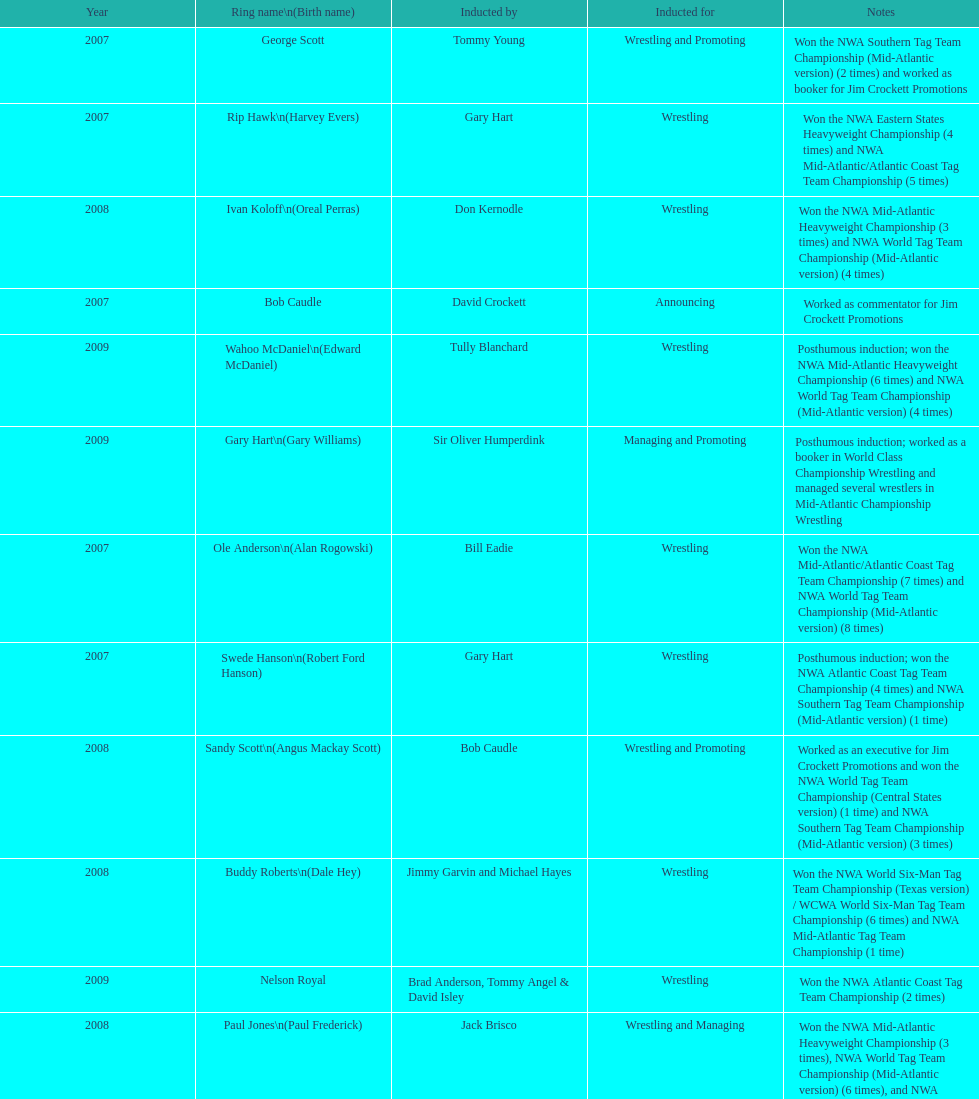Who was inducted after royal? Lance Russell. 